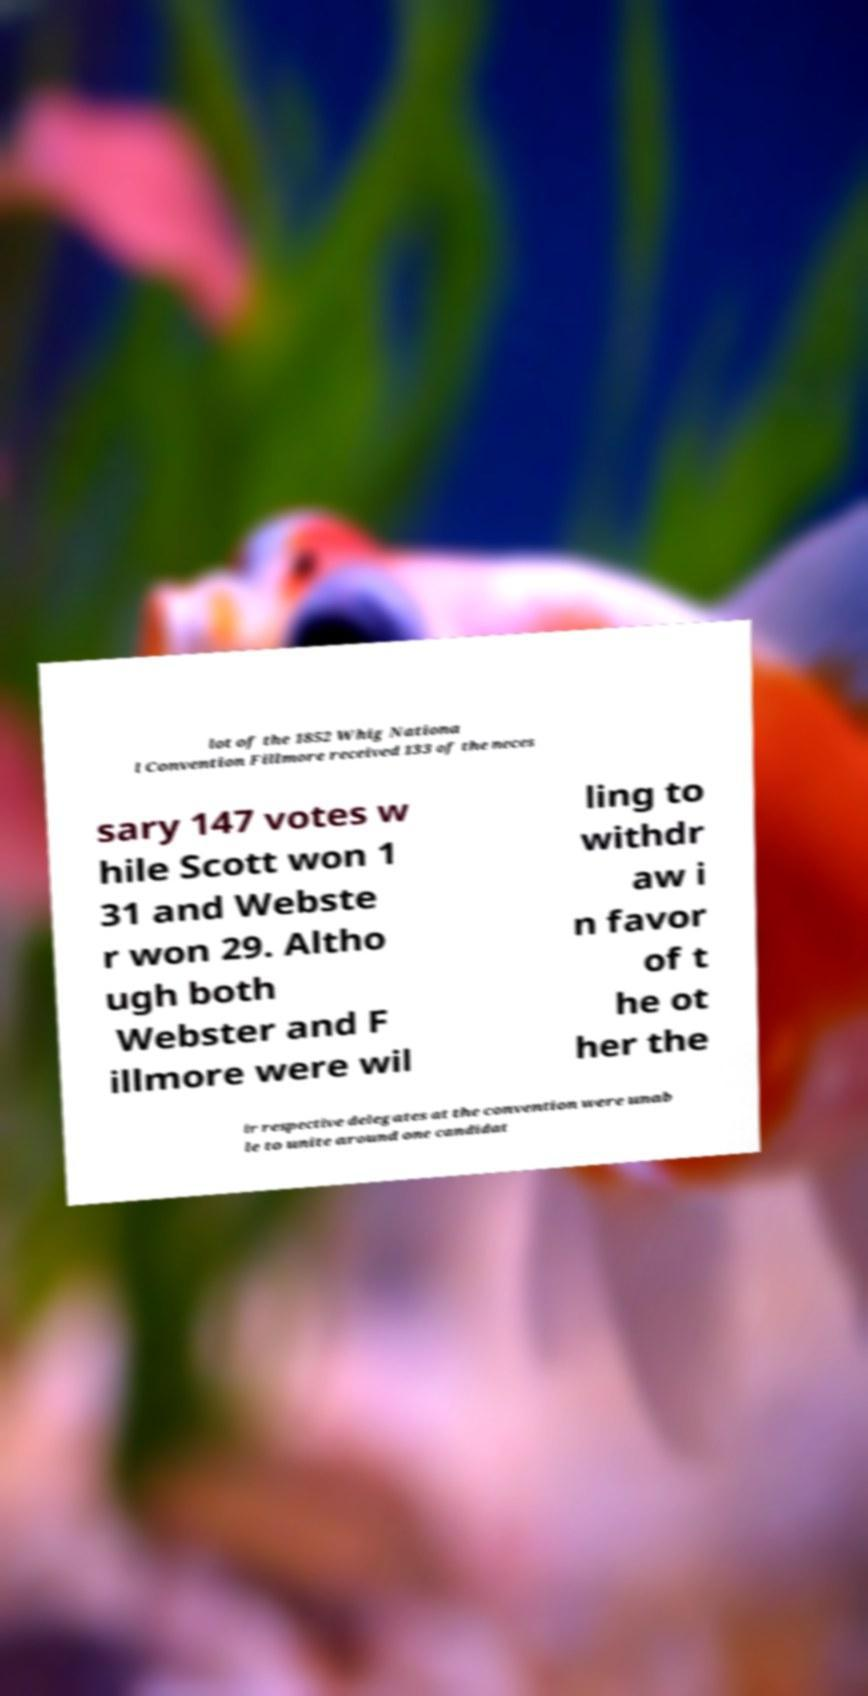I need the written content from this picture converted into text. Can you do that? lot of the 1852 Whig Nationa l Convention Fillmore received 133 of the neces sary 147 votes w hile Scott won 1 31 and Webste r won 29. Altho ugh both Webster and F illmore were wil ling to withdr aw i n favor of t he ot her the ir respective delegates at the convention were unab le to unite around one candidat 